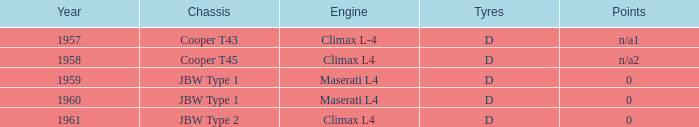What was the engine available during 1961? Climax L4. 